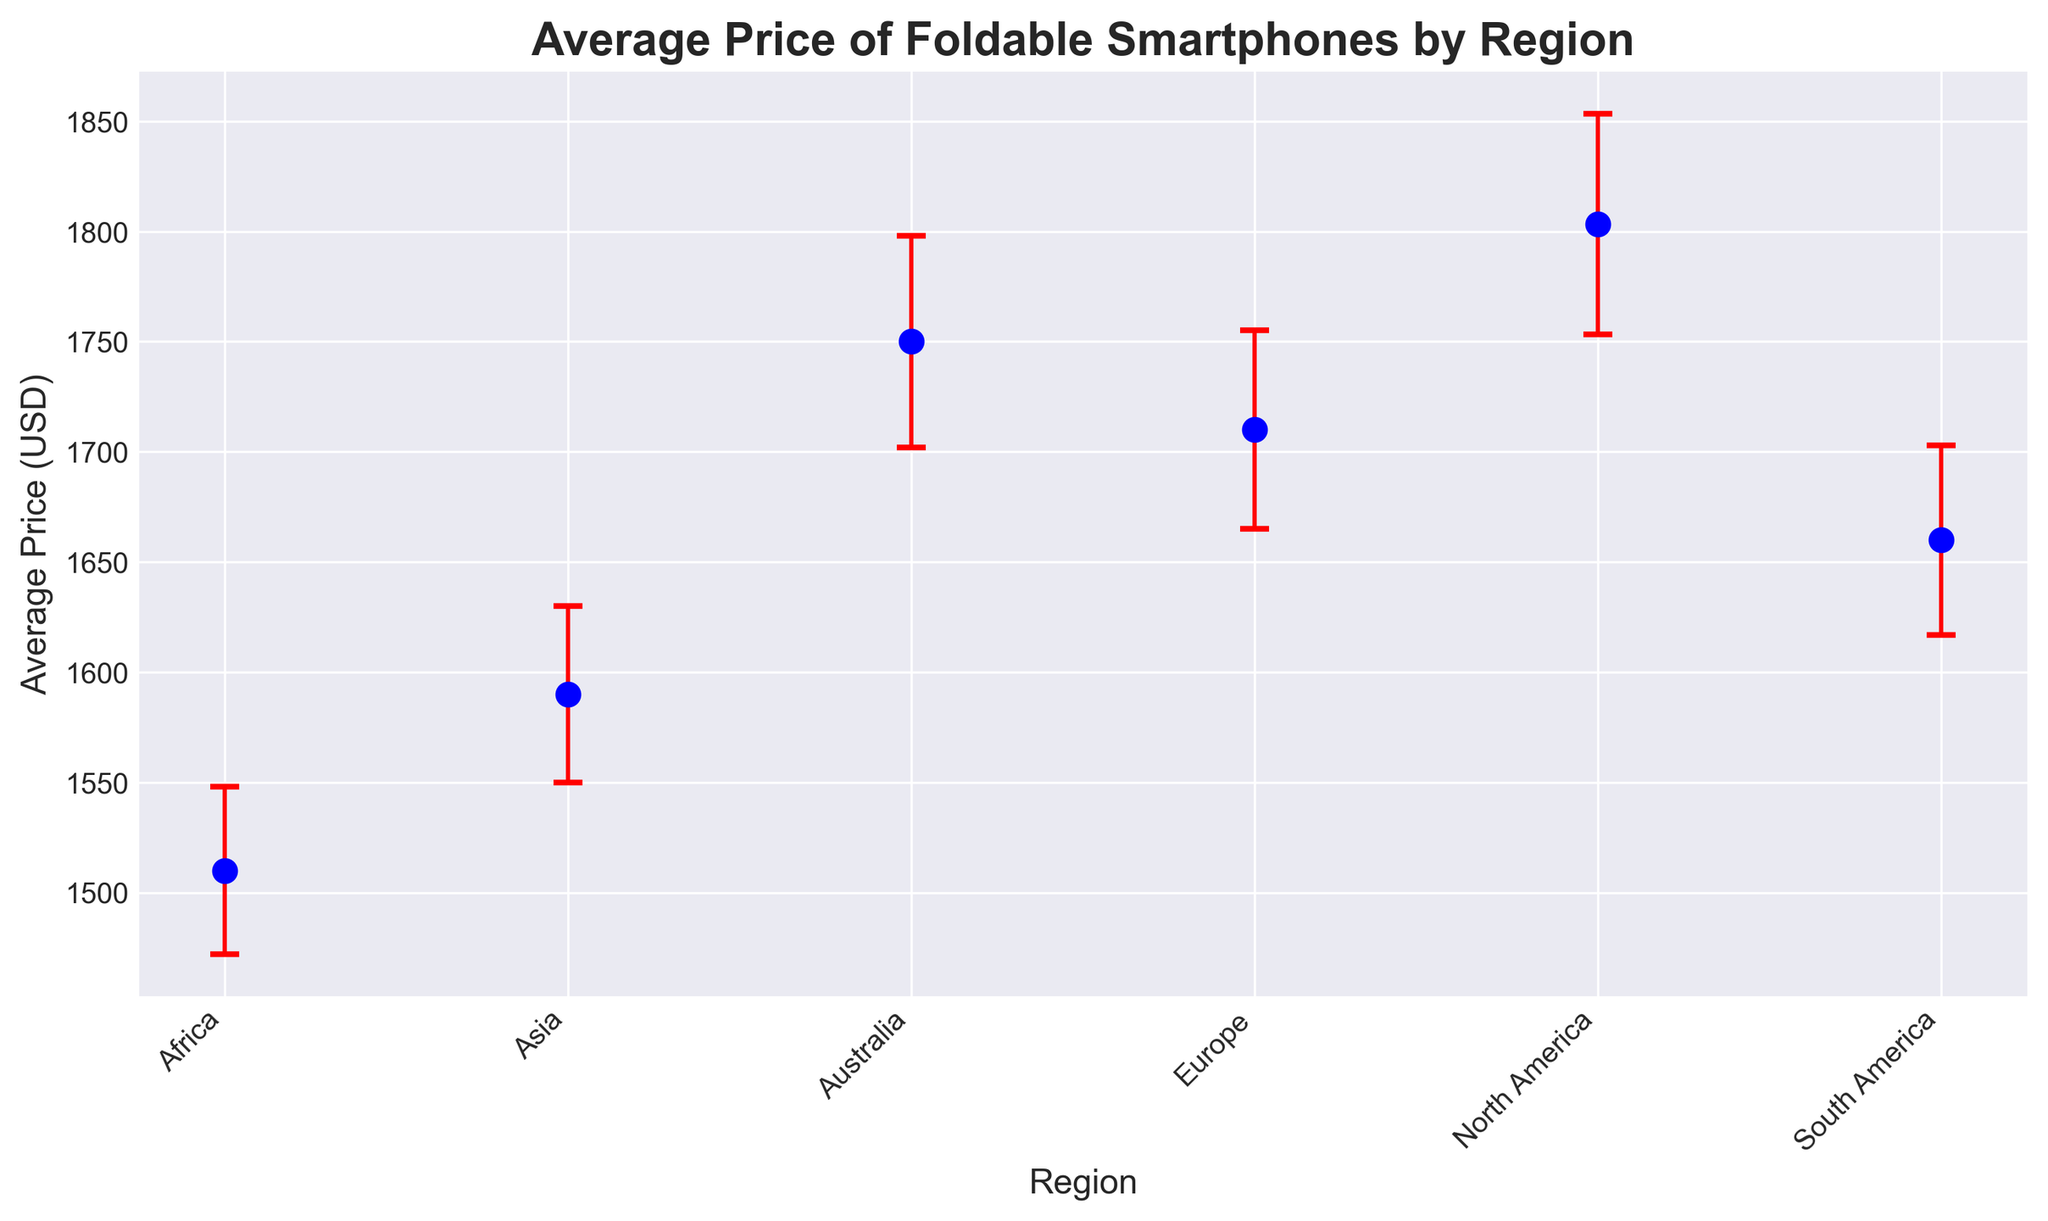What's the average price difference between North America and Africa? To find the average price difference, subtract the average price in Africa from that in North America. From the chart, North America's average price is $1803.33, and Africa's average price is $1510.00. So, $1803.33 - $1510.00 = $293.33.
Answer: $293.33 Which region has the lowest average price for foldable smartphones? Compare the average prices of all regions from the chart. Africa, with an average price of $1510.00, has the lowest price.
Answer: Africa How does the standard error in North America compare to Australia? Compare the standard error values on the plot for North America and Australia. North America has a standard error of approximately 50, and Australia has about 48. Therefore, North America's standard error is slightly higher.
Answer: North America Is the average price in Europe higher than in South America? Compare the average prices from the chart for Europe and South America. Europe's average price is $1710.00, and South America's is $1660.00. Since $1710.00 > $1660.00, Europe's price is higher.
Answer: Yes What is the total average price of foldable smartphones in Asia and Europe combined? Add the average prices of Asia and Europe from the chart. Asia's average price is $1590.00, and Europe's is $1710.00. Therefore, the total average price is $1590.00 + $1710.00 = $3300.00.
Answer: $3300.00 Which region shows the greatest variation (largest standard error) in average smartphone prices? Compare the standard error bars of all regions from the plot. North America has the largest standard error at approximately 50.
Answer: North America What is the range of average prices of foldable smartphones across all regions? Determine the highest and lowest average prices from the chart. The highest is North America at $1803.33 and the lowest is Africa at $1510.00. The range is $1803.33 - $1510.00 = $293.33.
Answer: $293.33 